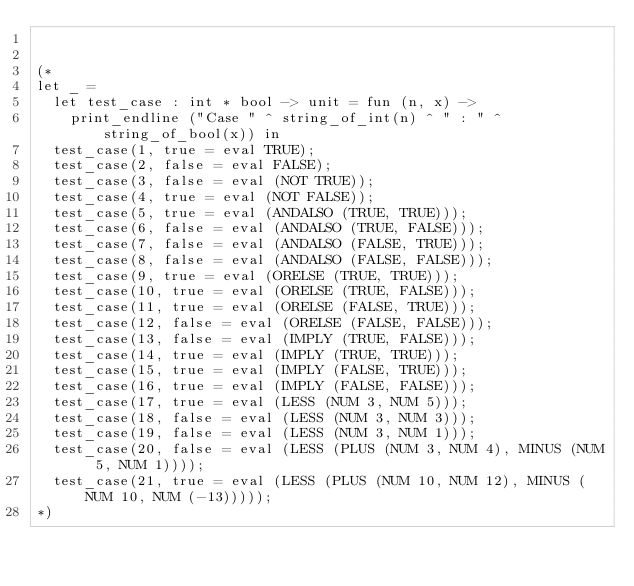<code> <loc_0><loc_0><loc_500><loc_500><_OCaml_>

(*
let _ = 
  let test_case : int * bool -> unit = fun (n, x) -> 
    print_endline ("Case " ^ string_of_int(n) ^ " : " ^ string_of_bool(x)) in 
  test_case(1, true = eval TRUE); 
  test_case(2, false = eval FALSE); 
  test_case(3, false = eval (NOT TRUE)); 
  test_case(4, true = eval (NOT FALSE)); 
  test_case(5, true = eval (ANDALSO (TRUE, TRUE))); 
  test_case(6, false = eval (ANDALSO (TRUE, FALSE))); 
  test_case(7, false = eval (ANDALSO (FALSE, TRUE))); 
  test_case(8, false = eval (ANDALSO (FALSE, FALSE))); 
  test_case(9, true = eval (ORELSE (TRUE, TRUE))); 
  test_case(10, true = eval (ORELSE (TRUE, FALSE))); 
  test_case(11, true = eval (ORELSE (FALSE, TRUE))); 
  test_case(12, false = eval (ORELSE (FALSE, FALSE))); 
  test_case(13, false = eval (IMPLY (TRUE, FALSE))); 
  test_case(14, true = eval (IMPLY (TRUE, TRUE))); 
  test_case(15, true = eval (IMPLY (FALSE, TRUE))); 
  test_case(16, true = eval (IMPLY (FALSE, FALSE))); 
  test_case(17, true = eval (LESS (NUM 3, NUM 5))); 
  test_case(18, false = eval (LESS (NUM 3, NUM 3))); 
  test_case(19, false = eval (LESS (NUM 3, NUM 1))); 
  test_case(20, false = eval (LESS (PLUS (NUM 3, NUM 4), MINUS (NUM 5, NUM 1)))); 
  test_case(21, true = eval (LESS (PLUS (NUM 10, NUM 12), MINUS (NUM 10, NUM (-13)))));
*)
</code> 